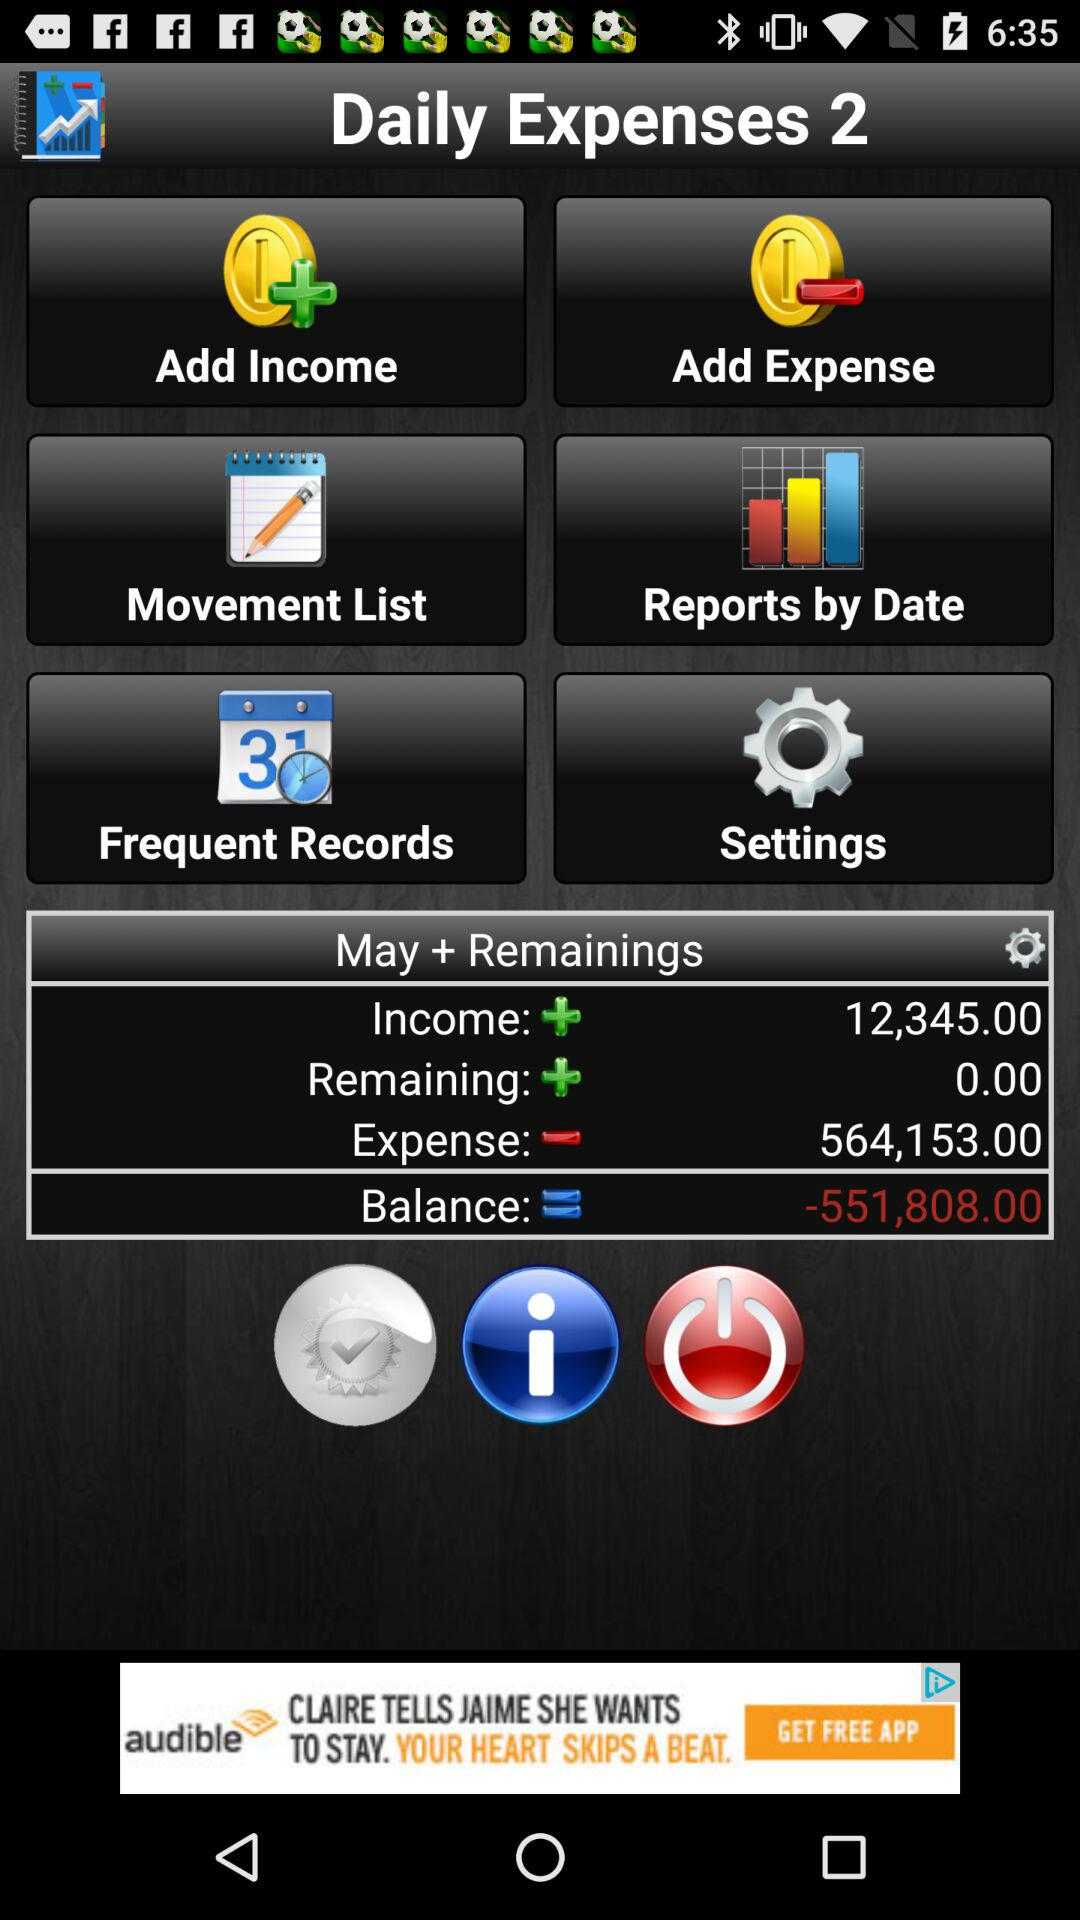How much is the total income? The total income is 12,345.00. 